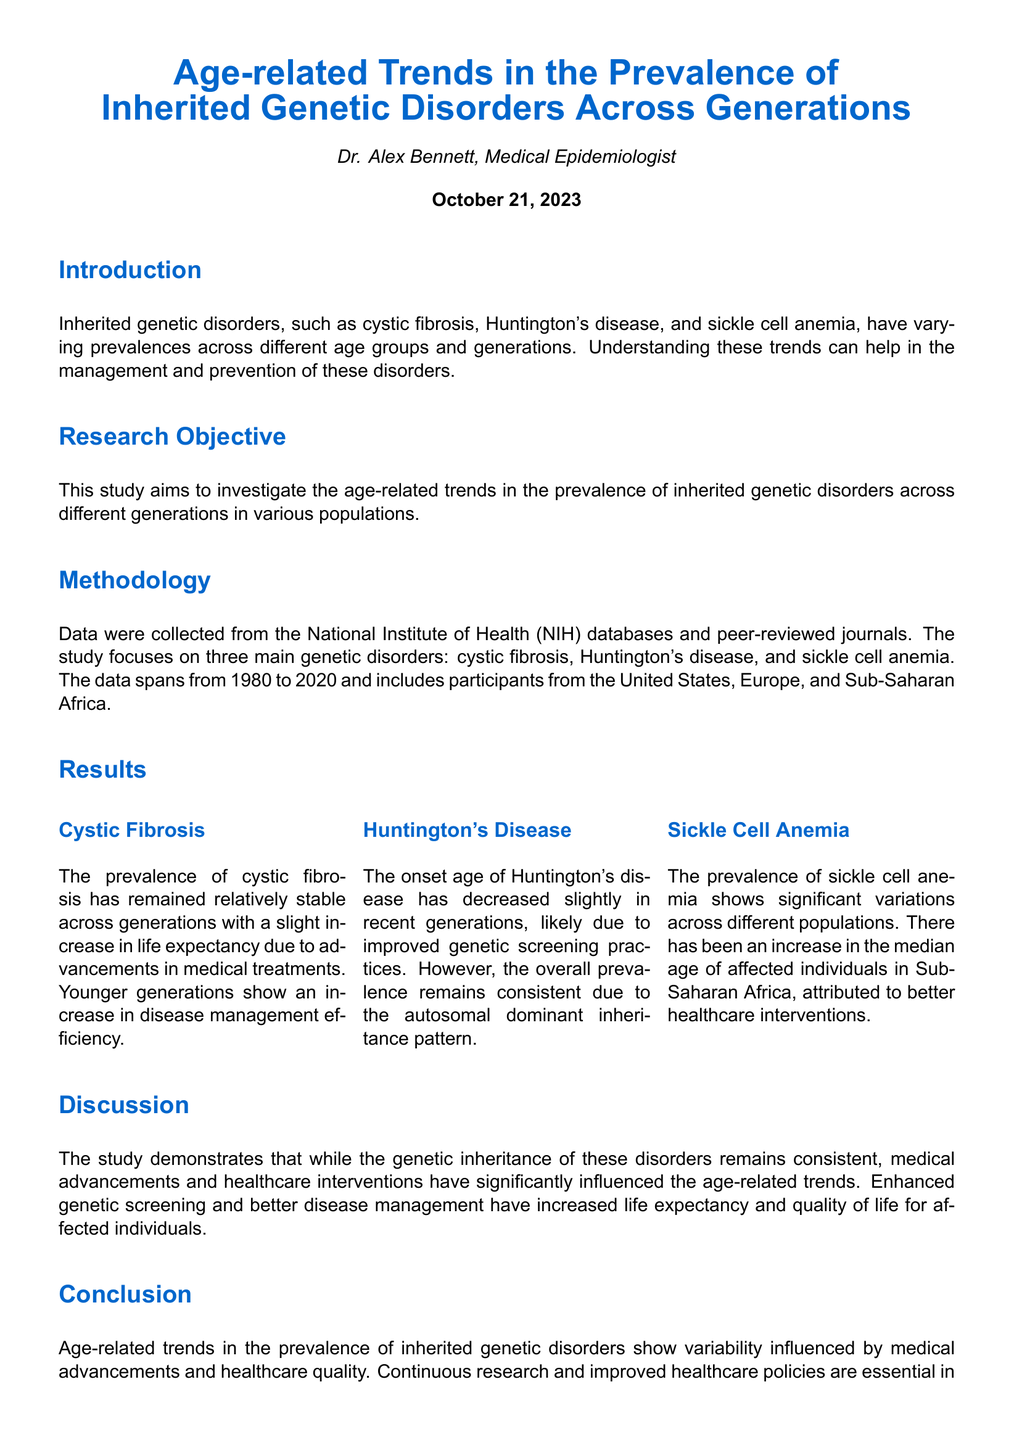what is the title of the report? The title is stated clearly at the beginning of the document as "Age-related Trends in the Prevalence of Inherited Genetic Disorders Across Generations."
Answer: Age-related Trends in the Prevalence of Inherited Genetic Disorders Across Generations who is the author of the report? The author's name is mentioned in the introduction section of the document as Dr. Alex Bennett.
Answer: Dr. Alex Bennett what genetic disorders are focused on in this study? The document lists cystic fibrosis, Huntington's disease, and sickle cell anemia as the main genetic disorders studied.
Answer: cystic fibrosis, Huntington's disease, and sickle cell anemia what year does the data span from? The document specifies that the data spans from 1980 to 2020.
Answer: 1980 to 2020 what was noted about the prevalence of cystic fibrosis? The report indicates that the prevalence of cystic fibrosis has remained relatively stable across generations.
Answer: relatively stable how has the onset age of Huntington's disease changed? The document mentions that the onset age of Huntington's disease has decreased slightly in recent generations.
Answer: decreased slightly what factor contributed to the increase in the median age of affected individuals with sickle cell anemia in Sub-Saharan Africa? The report attributes the increase in median age to better healthcare interventions.
Answer: better healthcare interventions what is highlighted as essential for managing genetic conditions across generations? The conclusion section emphasizes that continuous research and improved healthcare policies are essential.
Answer: continuous research and improved healthcare policies how is the stability of genetic inheritance described in the discussion section? The discussion notes that the genetic inheritance of these disorders remains consistent.
Answer: remains consistent 